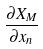Convert formula to latex. <formula><loc_0><loc_0><loc_500><loc_500>\frac { \partial X _ { M } } { \partial x _ { n } }</formula> 